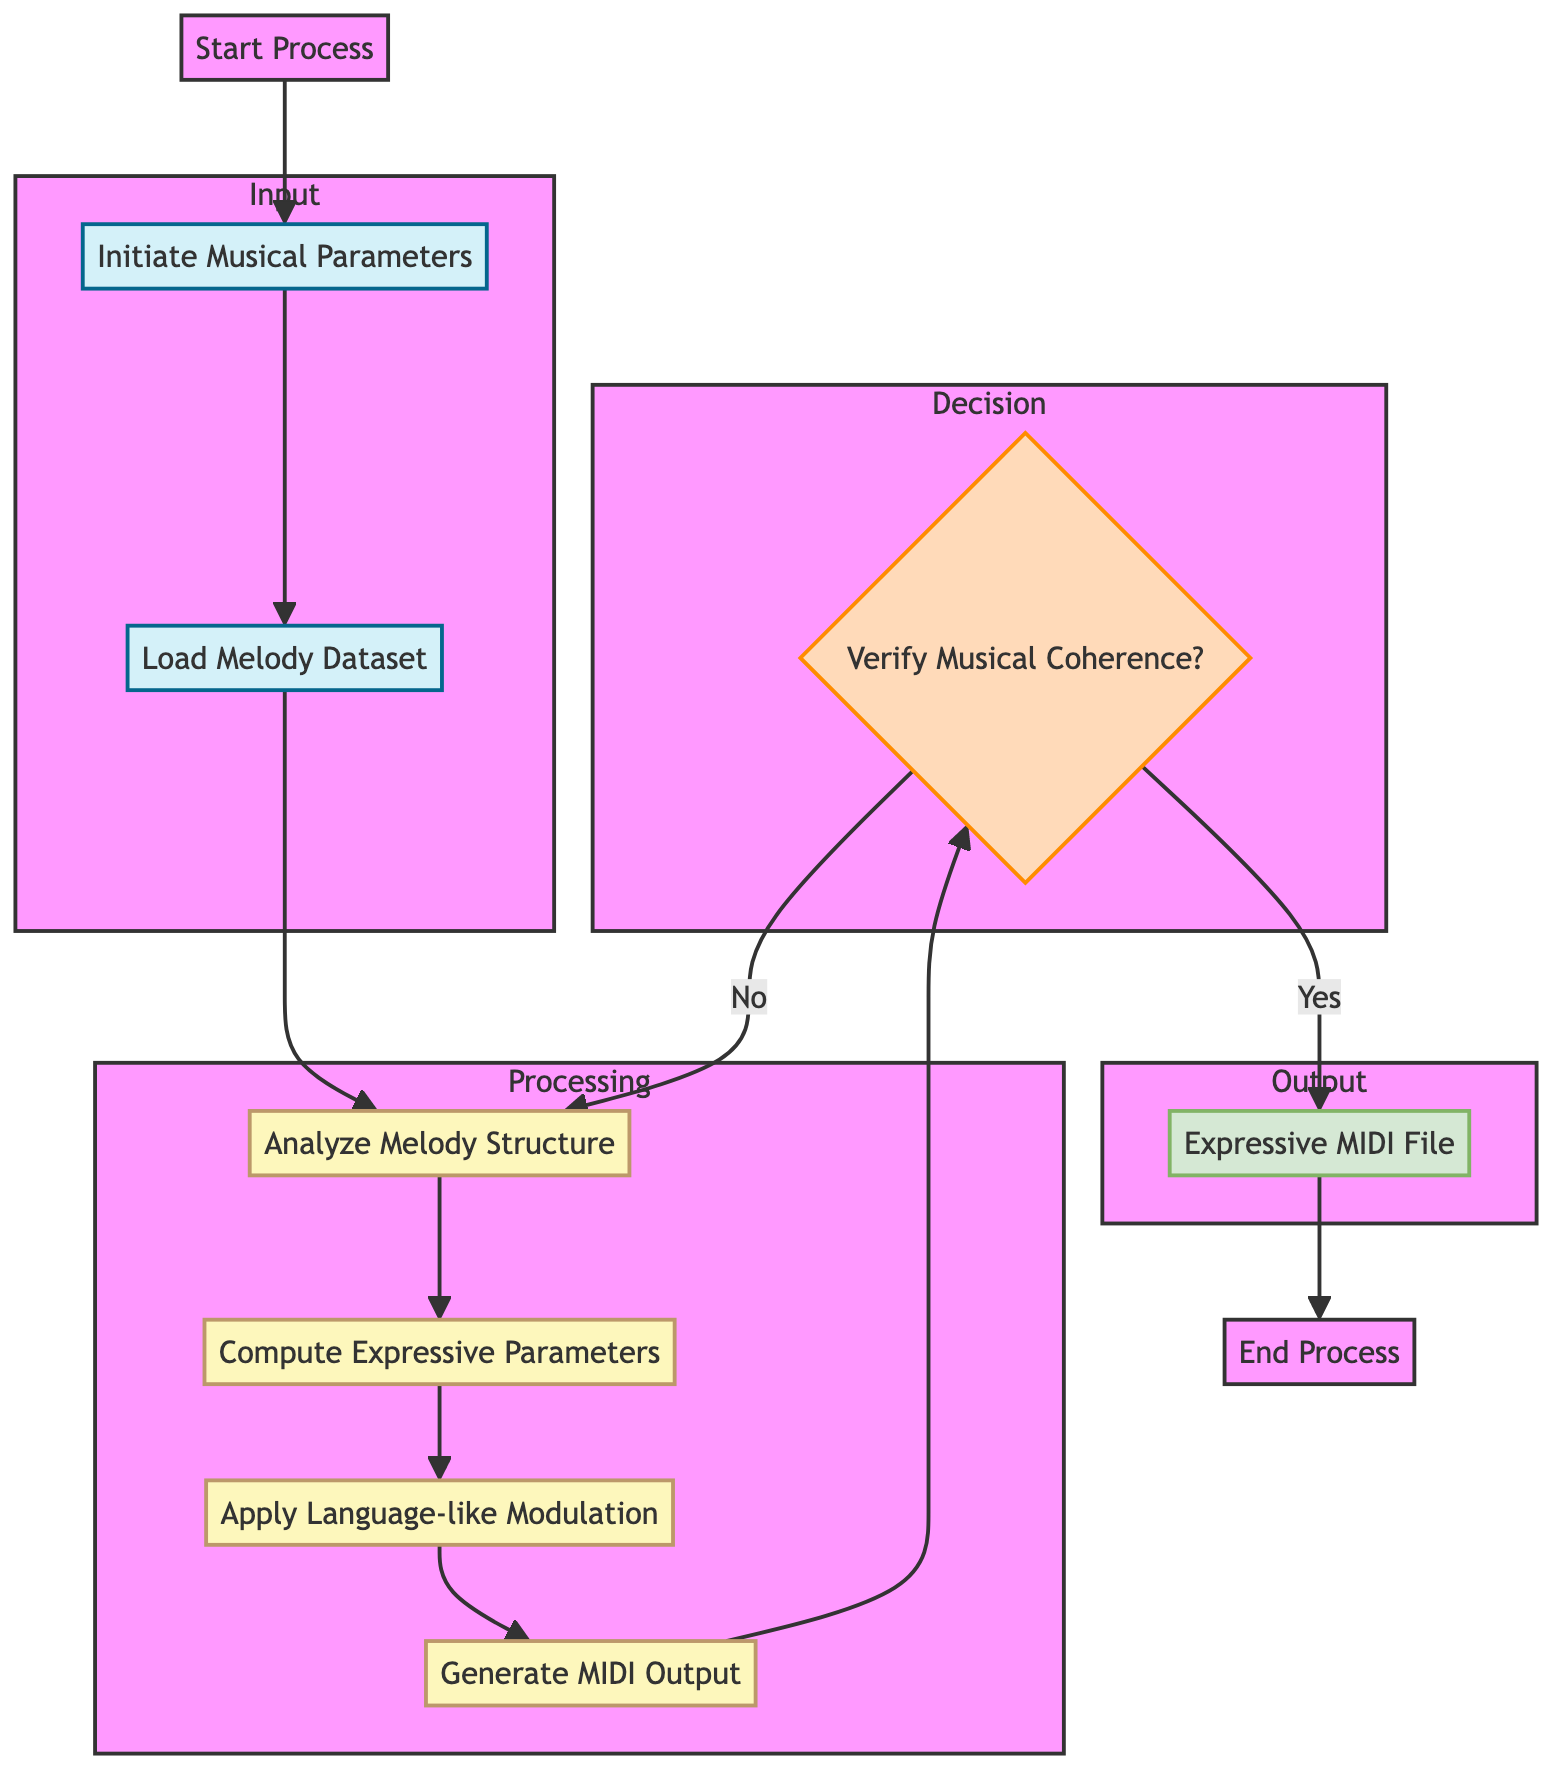What is the first action taken in this flowchart? The flowchart starts with the action labeled "Start Process," which signifies the beginning of the whole automated process for generating expressive musical phrases.
Answer: Start Process How many processing steps are there in the diagram? The diagram includes four processing steps: "Analyze Melody Structure," "Compute Expressive Parameters," "Apply Language-like Modulation," and "Generate MIDI Output," resulting in a total of four processing steps.
Answer: Four What are the parameters set at the beginning of the process? The initial parameters specified in the diagram are "Key Signature," "Tempo," and "Dynamics," which are crucial for initiating the musical generation process.
Answer: Key Signature, Tempo, Dynamics What happens if the musical coherence is not verified positively? If the musical coherence is not confirmed positively, the process returns to the "Analyze Melody Structure" step, indicating that further analysis is required for improvement before moving forward.
Answer: Analyze Melody Structure What is the final output of the process? The flowchart indicates that the final output is an "Expressive MIDI File," which is the end result of the automated music phrase generation process.
Answer: Expressive MIDI File How is expressivity applied based on the diagram? Expressivity is applied through the step labeled "Apply Language-like Modulation," where dynamics and tempo are adjusted to enhance the expressiveness of the generated musical phrases.
Answer: Apply Language-like Modulation Which element comes directly after loading the melody dataset? After the "Load Melody Dataset" step, the next action in the flowchart is to "Analyze Melody Structure," which signifies the analysis of the loaded music data.
Answer: Analyze Melody Structure What decision is made before finalizing the output? Before finalizing the output, the decision made is whether to verify the "Musical Coherence," determining if the output meets the required musical standards before saving it.
Answer: Verify Musical Coherence 